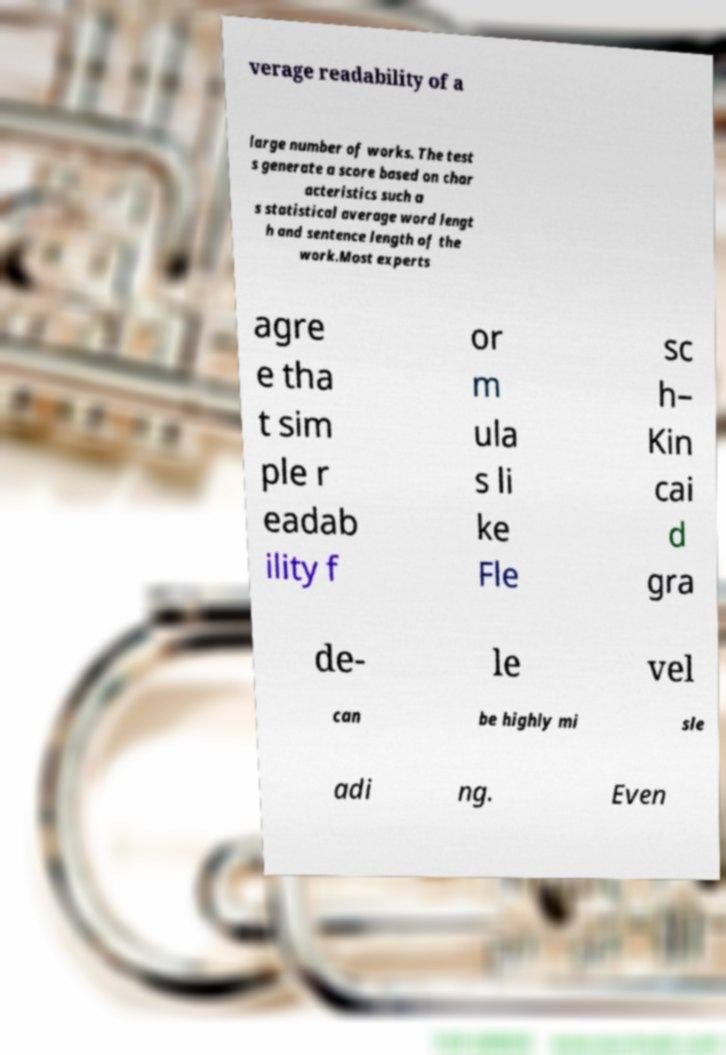Can you accurately transcribe the text from the provided image for me? verage readability of a large number of works. The test s generate a score based on char acteristics such a s statistical average word lengt h and sentence length of the work.Most experts agre e tha t sim ple r eadab ility f or m ula s li ke Fle sc h– Kin cai d gra de- le vel can be highly mi sle adi ng. Even 